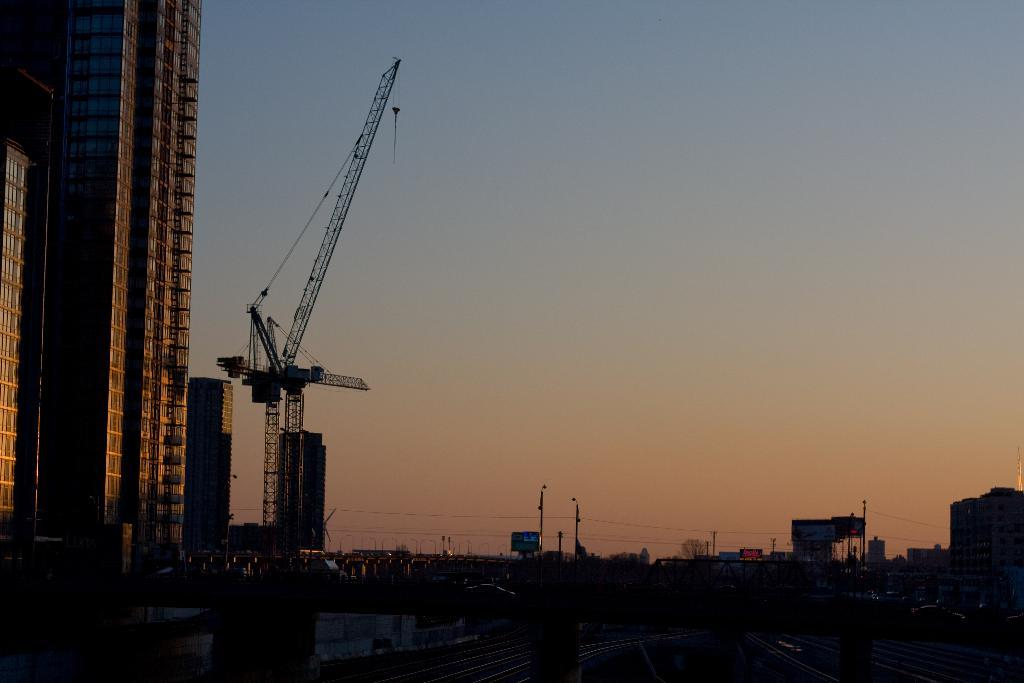What structures are located on the left side of the image? There are buildings on the left side of the image. What construction equipment can be seen in the image? There is a crane in the image. What type of infrastructure is present in the image? There are electric poles and wires in the image. What is visible at the top of the image? The sky is visible at the top of the image. How many fish can be seen swimming in the image? There are no fish present in the image. What type of wave is depicted in the image? There is no wave depicted in the image. 